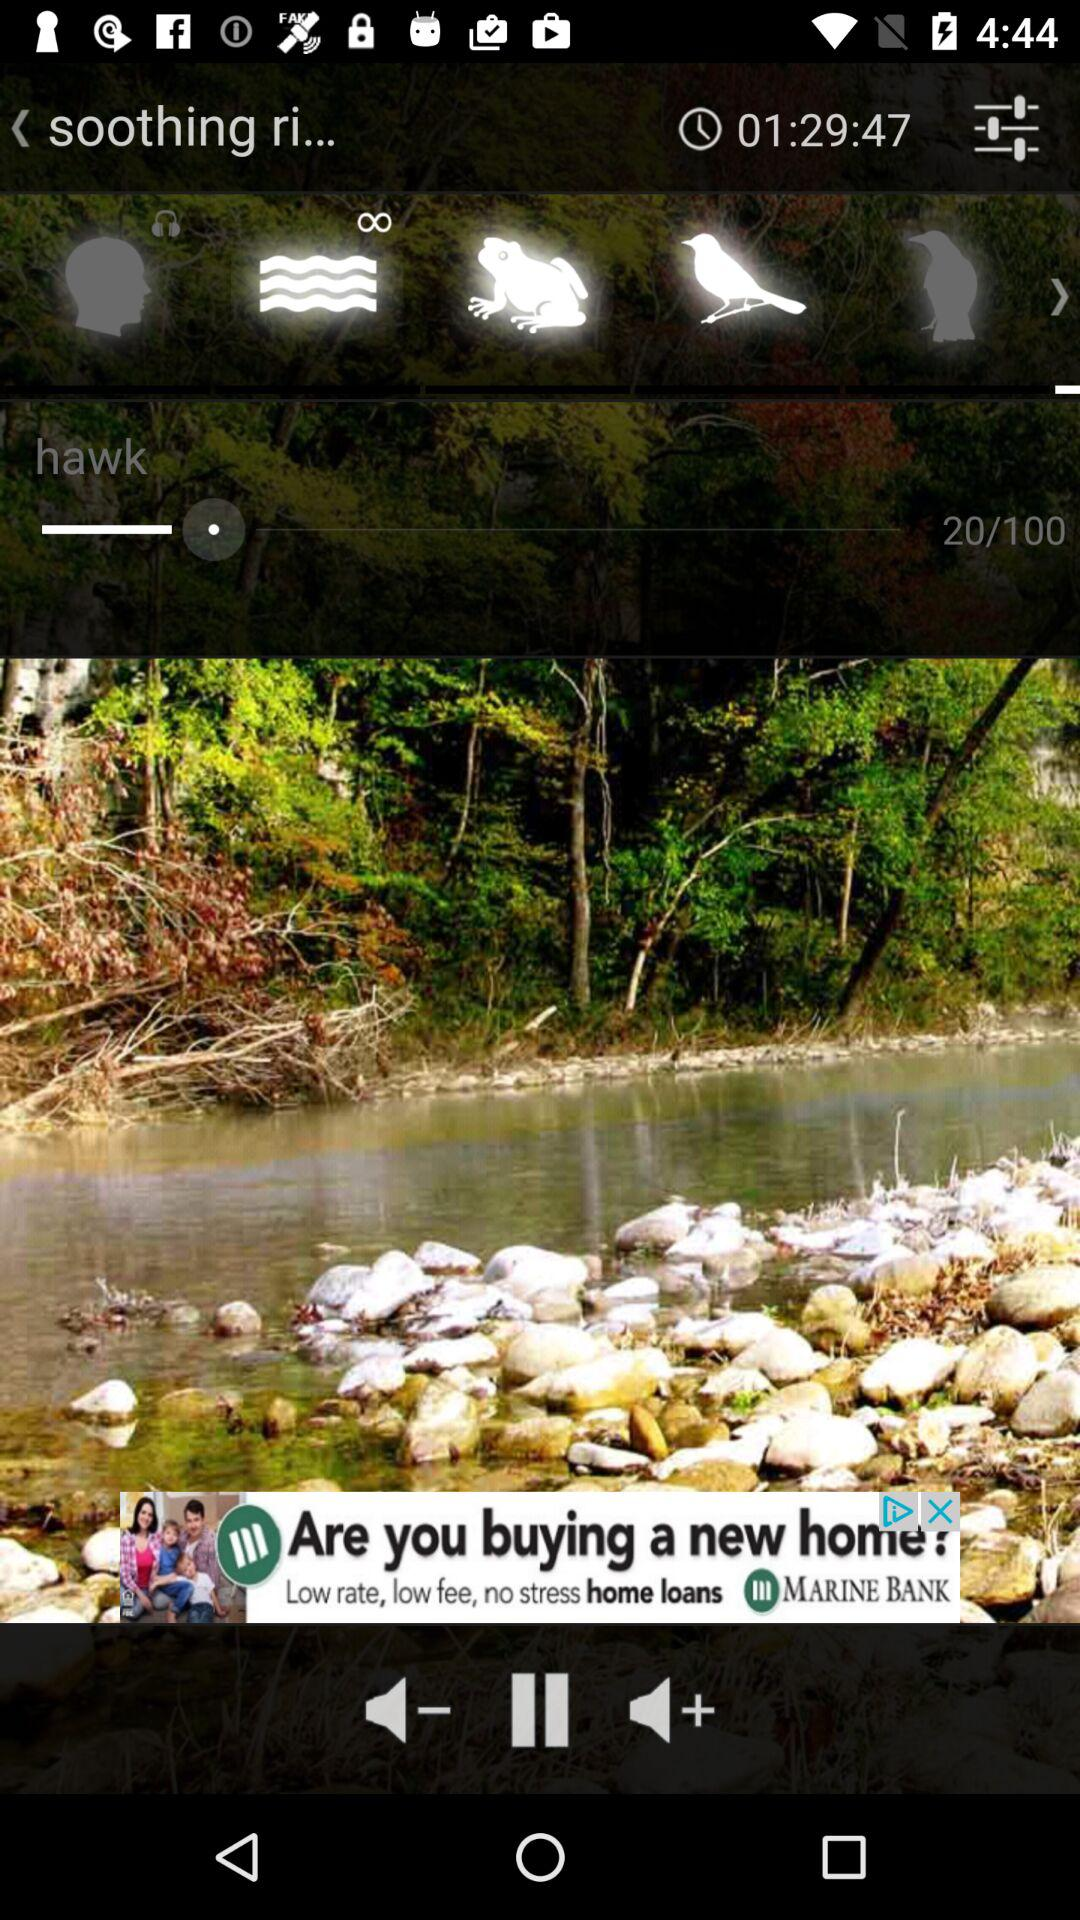What is the current page number?
When the provided information is insufficient, respond with <no answer>. <no answer> 